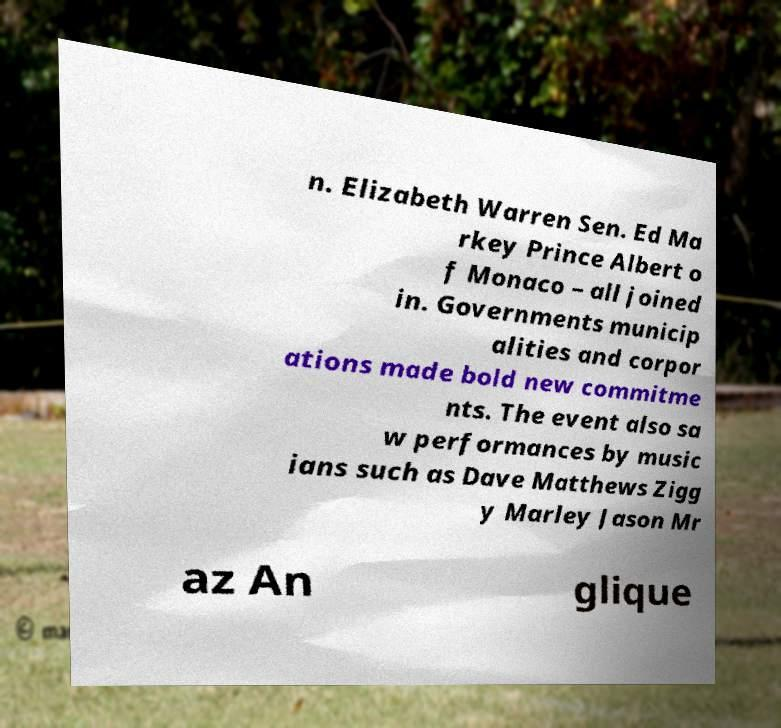For documentation purposes, I need the text within this image transcribed. Could you provide that? n. Elizabeth Warren Sen. Ed Ma rkey Prince Albert o f Monaco – all joined in. Governments municip alities and corpor ations made bold new commitme nts. The event also sa w performances by music ians such as Dave Matthews Zigg y Marley Jason Mr az An glique 